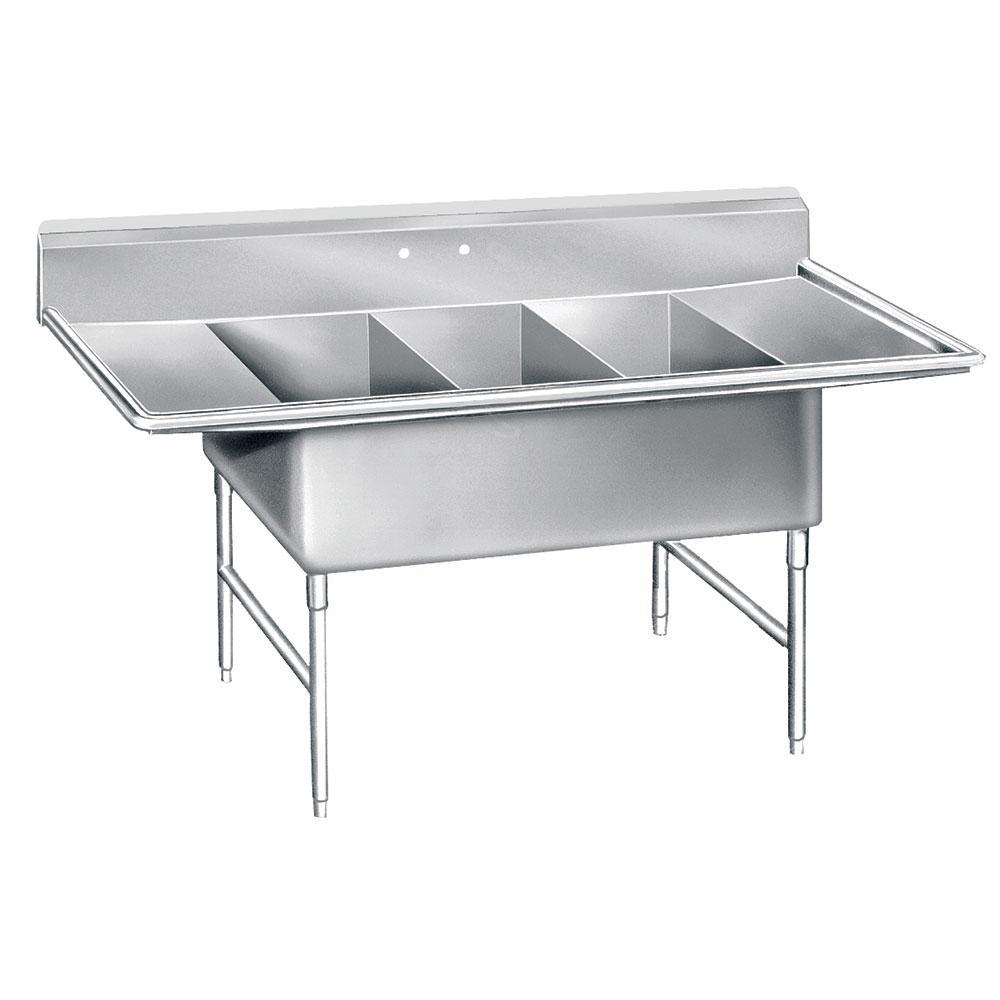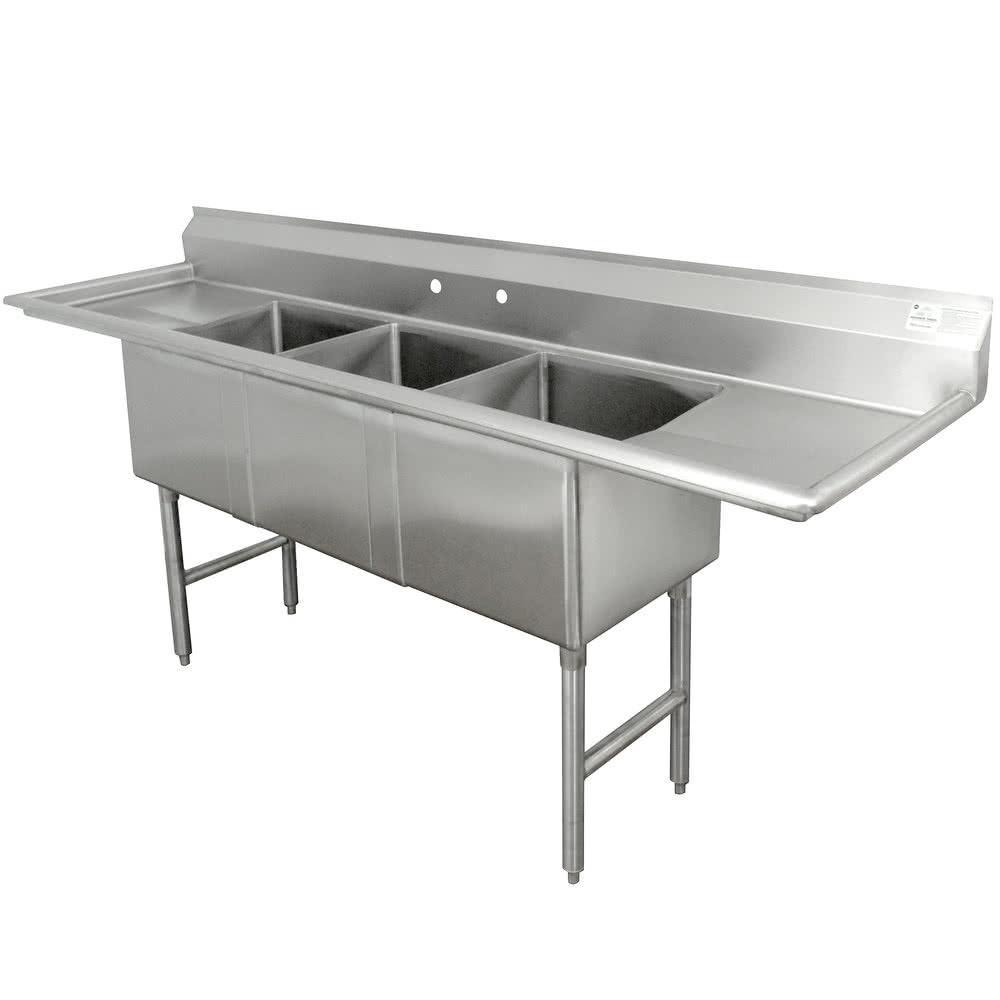The first image is the image on the left, the second image is the image on the right. Given the left and right images, does the statement "In at least one image there is a three basin sink with a a long left washing counter." hold true? Answer yes or no. No. The first image is the image on the left, the second image is the image on the right. Analyze the images presented: Is the assertion "Each image contains a three part sink without a faucet" valid? Answer yes or no. Yes. 